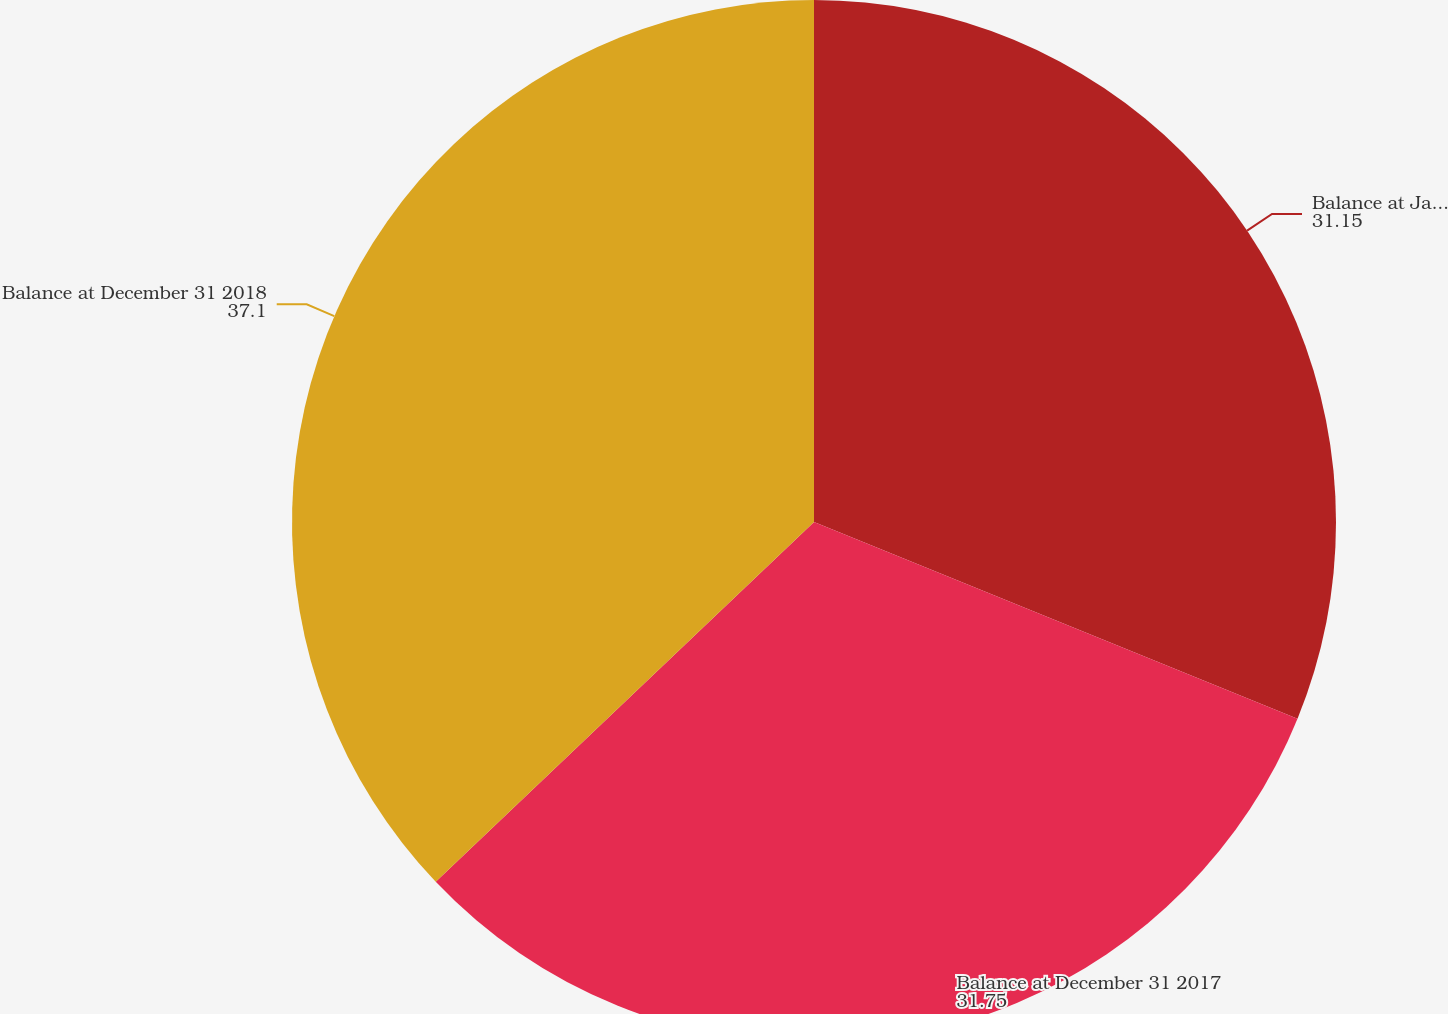Convert chart. <chart><loc_0><loc_0><loc_500><loc_500><pie_chart><fcel>Balance at January 1 2017<fcel>Balance at December 31 2017<fcel>Balance at December 31 2018<nl><fcel>31.15%<fcel>31.75%<fcel>37.1%<nl></chart> 